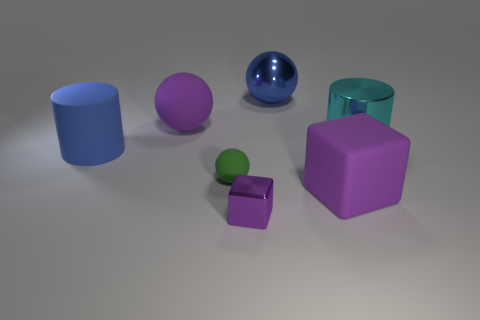There is a rubber object that is the same color as the big rubber block; what shape is it?
Keep it short and to the point. Sphere. There is a cyan cylinder; does it have the same size as the metallic object in front of the big blue matte object?
Your answer should be very brief. No. Are there more tiny things that are behind the tiny purple thing than small blue rubber spheres?
Your answer should be very brief. Yes. There is a purple cube that is the same material as the blue ball; what is its size?
Your answer should be compact. Small. Are there any large matte things that have the same color as the large metal ball?
Your response must be concise. Yes. What number of objects are big matte cylinders or purple objects that are in front of the matte cylinder?
Your answer should be compact. 3. Are there more green objects than cyan metallic blocks?
Provide a short and direct response. Yes. What is the size of the matte sphere that is the same color as the metallic cube?
Keep it short and to the point. Large. Is there a small ball that has the same material as the big cube?
Offer a very short reply. Yes. What shape is the large rubber thing that is behind the matte block and in front of the cyan thing?
Ensure brevity in your answer.  Cylinder. 